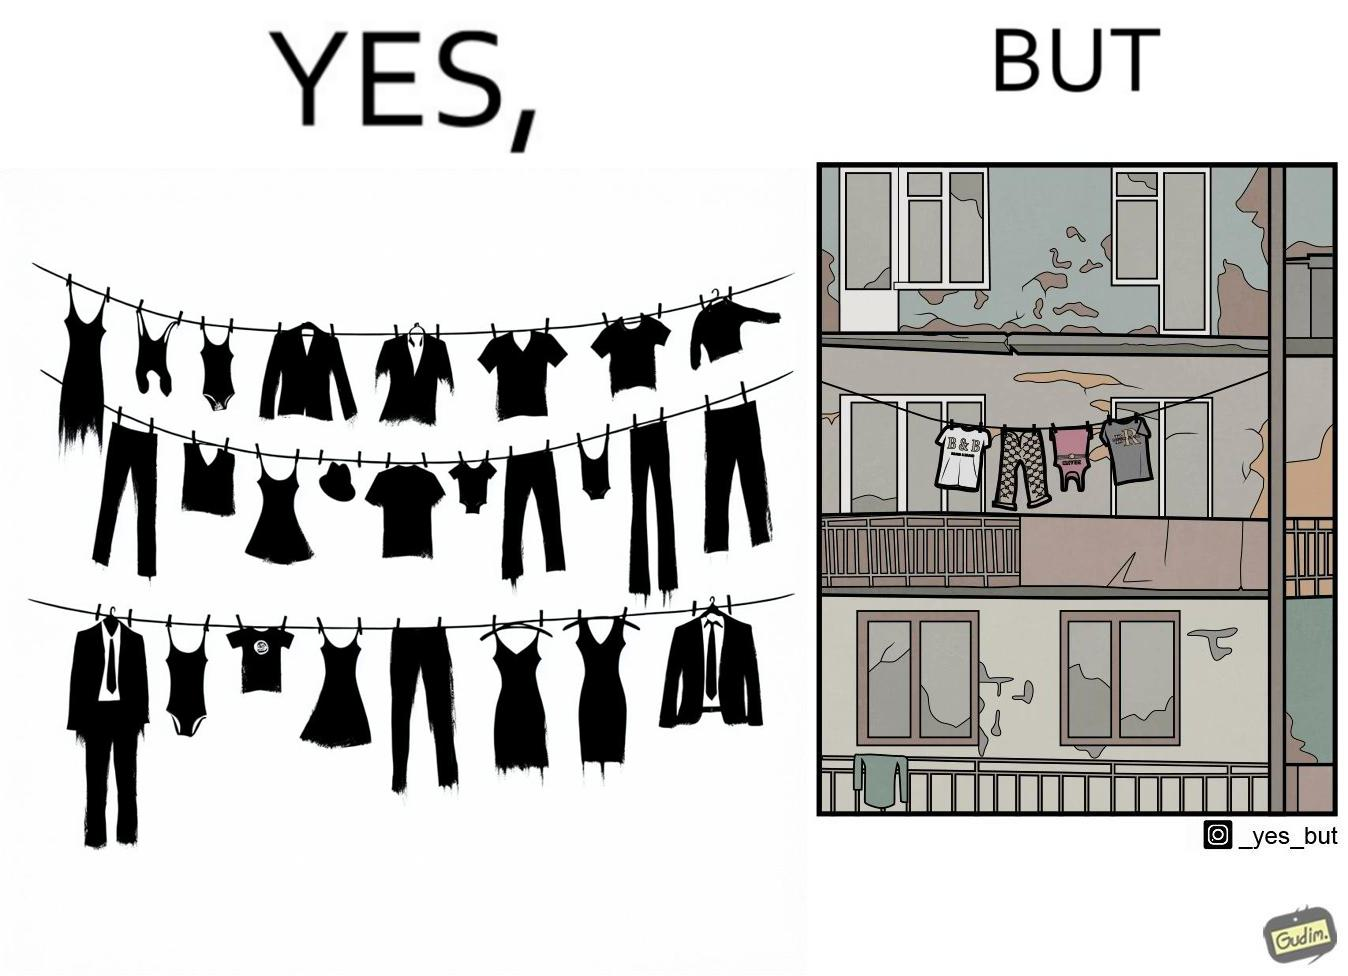What is shown in this image? The image is ironic because although the clothes are of branded companies but they are hanging in very poor building. 